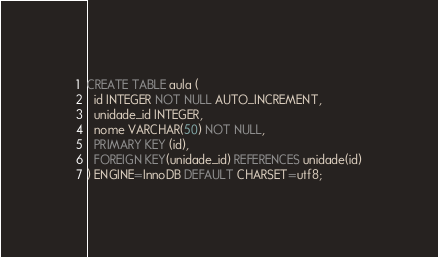<code> <loc_0><loc_0><loc_500><loc_500><_SQL_>CREATE TABLE aula (
  id INTEGER NOT NULL AUTO_INCREMENT,
  unidade_id INTEGER,
  nome VARCHAR(50) NOT NULL,
  PRIMARY KEY (id),
  FOREIGN KEY(unidade_id) REFERENCES unidade(id)
) ENGINE=InnoDB DEFAULT CHARSET=utf8;
</code> 